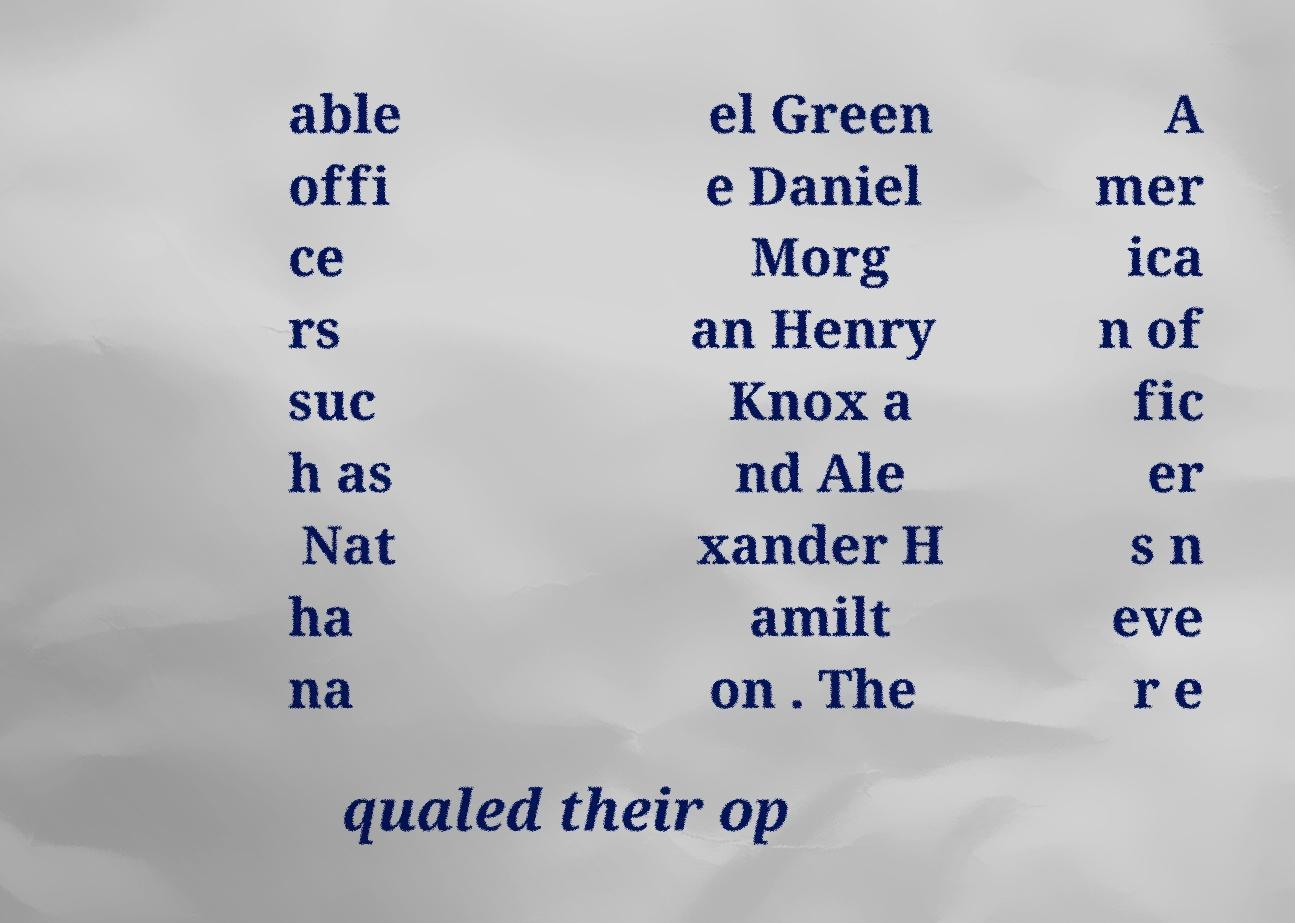There's text embedded in this image that I need extracted. Can you transcribe it verbatim? able offi ce rs suc h as Nat ha na el Green e Daniel Morg an Henry Knox a nd Ale xander H amilt on . The A mer ica n of fic er s n eve r e qualed their op 